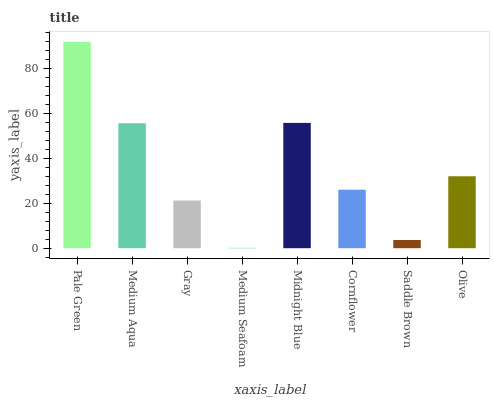Is Medium Aqua the minimum?
Answer yes or no. No. Is Medium Aqua the maximum?
Answer yes or no. No. Is Pale Green greater than Medium Aqua?
Answer yes or no. Yes. Is Medium Aqua less than Pale Green?
Answer yes or no. Yes. Is Medium Aqua greater than Pale Green?
Answer yes or no. No. Is Pale Green less than Medium Aqua?
Answer yes or no. No. Is Olive the high median?
Answer yes or no. Yes. Is Cornflower the low median?
Answer yes or no. Yes. Is Gray the high median?
Answer yes or no. No. Is Olive the low median?
Answer yes or no. No. 